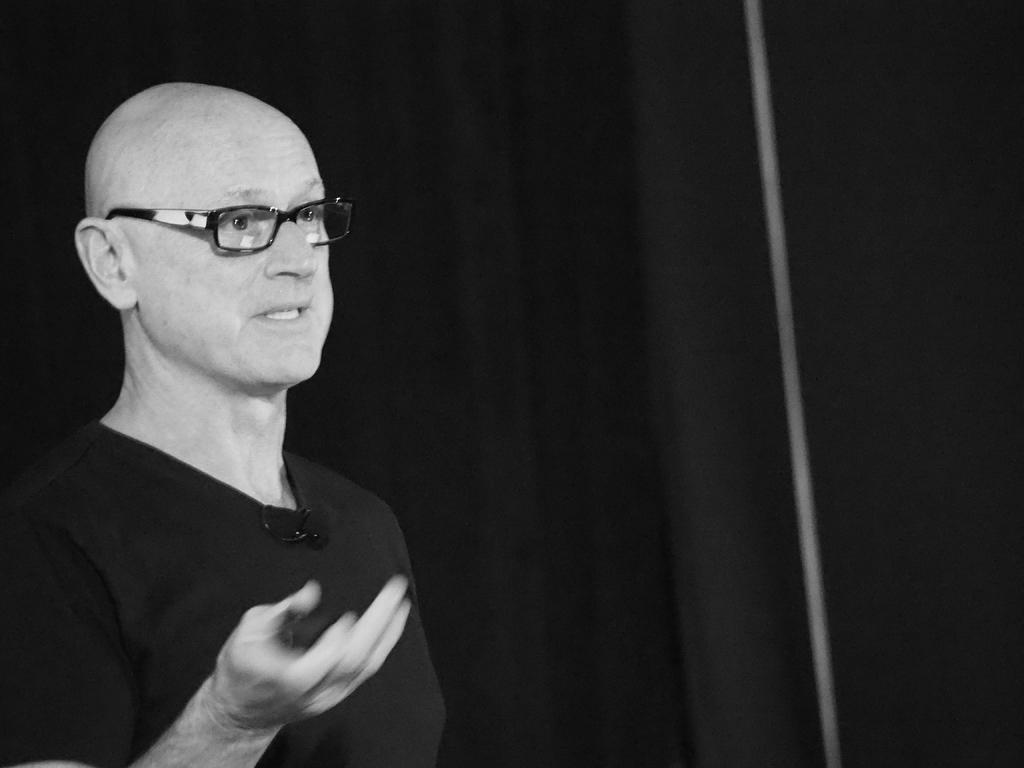What is located on the left side of the image? There is a man on the left side of the image. What is the man wearing in the image? The man is wearing spectacles in the image. What is the man doing in the image? The man appears to be talking in the image. What can be seen in the background of the image? There is a black curtain in the background of the image. Can you see the canvas on which the man is painting in the image? There is no canvas or painting activity present in the image. Is the man kissing someone in the image? There is no kissing or romantic interaction depicted in the image. 